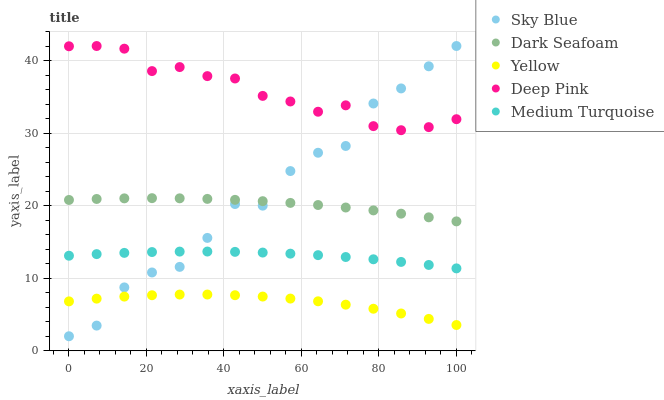Does Yellow have the minimum area under the curve?
Answer yes or no. Yes. Does Deep Pink have the maximum area under the curve?
Answer yes or no. Yes. Does Dark Seafoam have the minimum area under the curve?
Answer yes or no. No. Does Dark Seafoam have the maximum area under the curve?
Answer yes or no. No. Is Medium Turquoise the smoothest?
Answer yes or no. Yes. Is Sky Blue the roughest?
Answer yes or no. Yes. Is Dark Seafoam the smoothest?
Answer yes or no. No. Is Dark Seafoam the roughest?
Answer yes or no. No. Does Sky Blue have the lowest value?
Answer yes or no. Yes. Does Dark Seafoam have the lowest value?
Answer yes or no. No. Does Deep Pink have the highest value?
Answer yes or no. Yes. Does Dark Seafoam have the highest value?
Answer yes or no. No. Is Yellow less than Medium Turquoise?
Answer yes or no. Yes. Is Dark Seafoam greater than Medium Turquoise?
Answer yes or no. Yes. Does Sky Blue intersect Yellow?
Answer yes or no. Yes. Is Sky Blue less than Yellow?
Answer yes or no. No. Is Sky Blue greater than Yellow?
Answer yes or no. No. Does Yellow intersect Medium Turquoise?
Answer yes or no. No. 